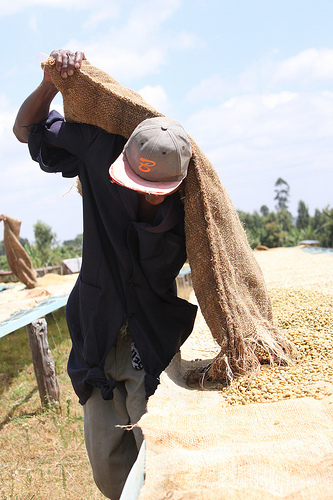<image>
Can you confirm if the tree is under the sky? Yes. The tree is positioned underneath the sky, with the sky above it in the vertical space. Where is the post in relation to the man? Is it under the man? No. The post is not positioned under the man. The vertical relationship between these objects is different. 